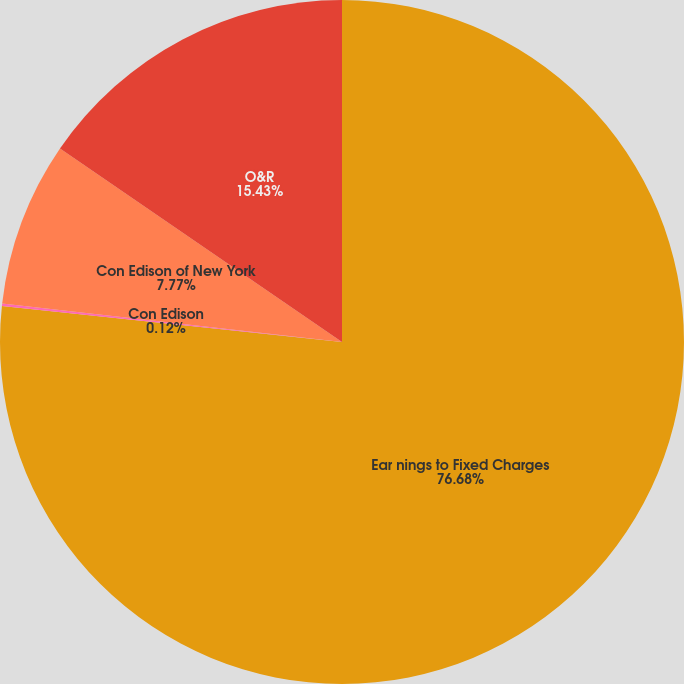Convert chart to OTSL. <chart><loc_0><loc_0><loc_500><loc_500><pie_chart><fcel>Ear nings to Fixed Charges<fcel>Con Edison<fcel>Con Edison of New York<fcel>O&R<nl><fcel>76.68%<fcel>0.12%<fcel>7.77%<fcel>15.43%<nl></chart> 